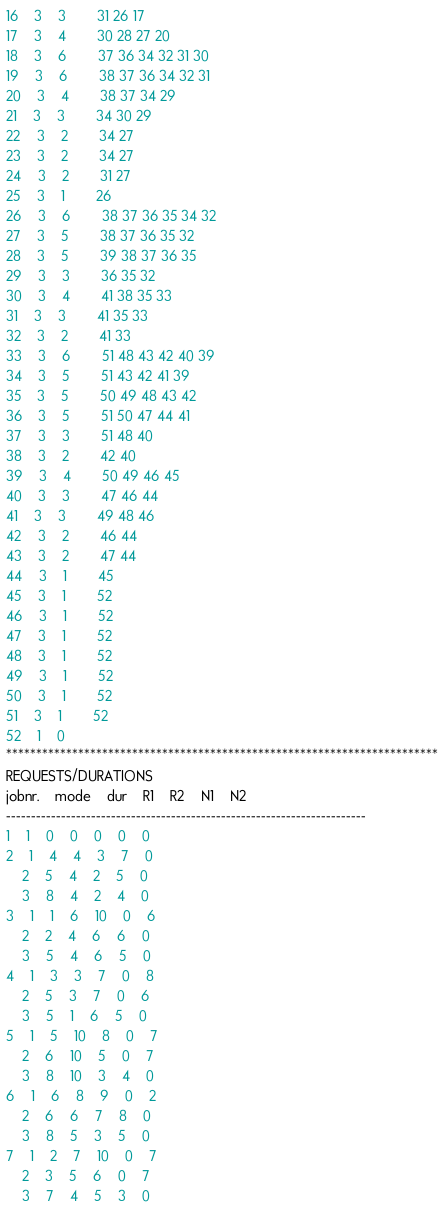Convert code to text. <code><loc_0><loc_0><loc_500><loc_500><_ObjectiveC_>16	3	3		31 26 17 
17	3	4		30 28 27 20 
18	3	6		37 36 34 32 31 30 
19	3	6		38 37 36 34 32 31 
20	3	4		38 37 34 29 
21	3	3		34 30 29 
22	3	2		34 27 
23	3	2		34 27 
24	3	2		31 27 
25	3	1		26 
26	3	6		38 37 36 35 34 32 
27	3	5		38 37 36 35 32 
28	3	5		39 38 37 36 35 
29	3	3		36 35 32 
30	3	4		41 38 35 33 
31	3	3		41 35 33 
32	3	2		41 33 
33	3	6		51 48 43 42 40 39 
34	3	5		51 43 42 41 39 
35	3	5		50 49 48 43 42 
36	3	5		51 50 47 44 41 
37	3	3		51 48 40 
38	3	2		42 40 
39	3	4		50 49 46 45 
40	3	3		47 46 44 
41	3	3		49 48 46 
42	3	2		46 44 
43	3	2		47 44 
44	3	1		45 
45	3	1		52 
46	3	1		52 
47	3	1		52 
48	3	1		52 
49	3	1		52 
50	3	1		52 
51	3	1		52 
52	1	0		
************************************************************************
REQUESTS/DURATIONS
jobnr.	mode	dur	R1	R2	N1	N2	
------------------------------------------------------------------------
1	1	0	0	0	0	0	
2	1	4	4	3	7	0	
	2	5	4	2	5	0	
	3	8	4	2	4	0	
3	1	1	6	10	0	6	
	2	2	4	6	6	0	
	3	5	4	6	5	0	
4	1	3	3	7	0	8	
	2	5	3	7	0	6	
	3	5	1	6	5	0	
5	1	5	10	8	0	7	
	2	6	10	5	0	7	
	3	8	10	3	4	0	
6	1	6	8	9	0	2	
	2	6	6	7	8	0	
	3	8	5	3	5	0	
7	1	2	7	10	0	7	
	2	3	5	6	0	7	
	3	7	4	5	3	0	</code> 